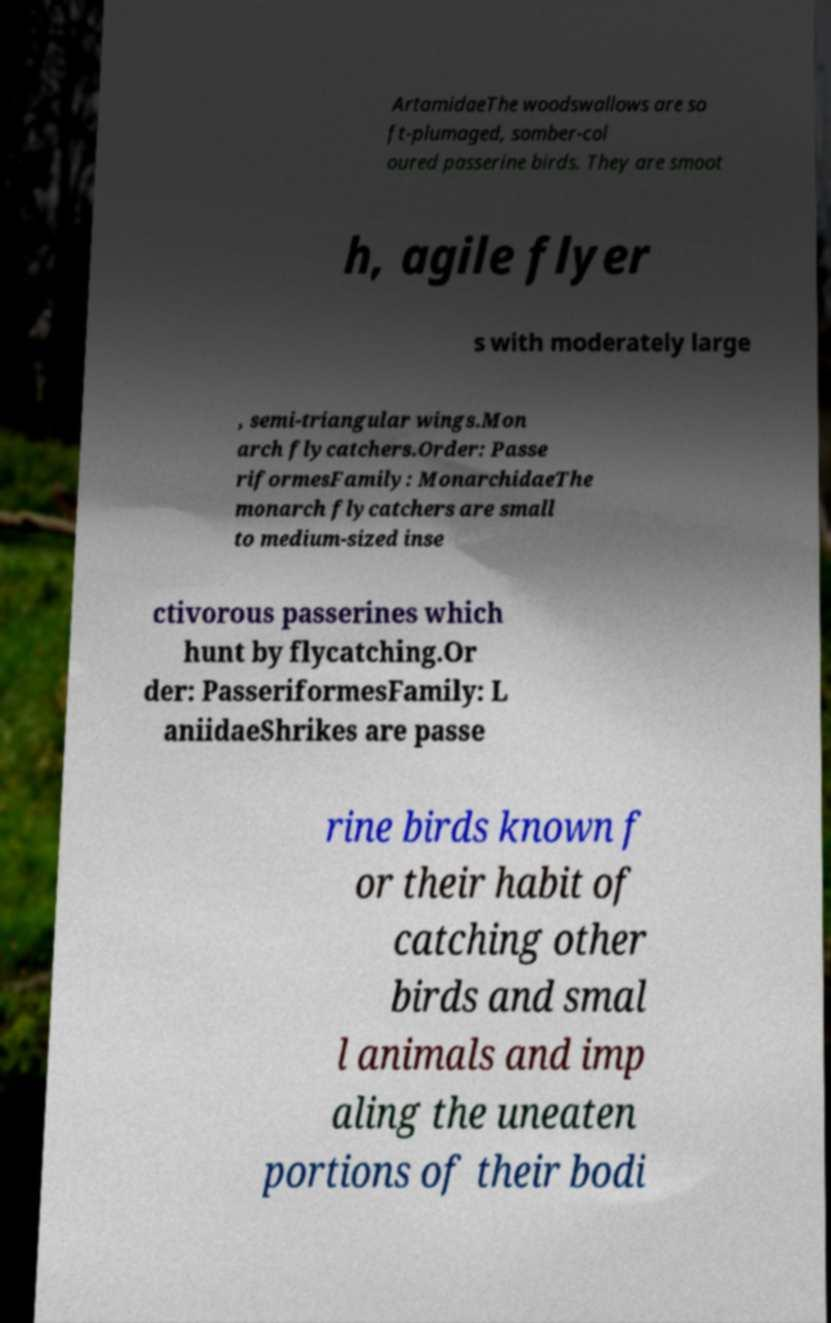Can you read and provide the text displayed in the image?This photo seems to have some interesting text. Can you extract and type it out for me? ArtamidaeThe woodswallows are so ft-plumaged, somber-col oured passerine birds. They are smoot h, agile flyer s with moderately large , semi-triangular wings.Mon arch flycatchers.Order: Passe riformesFamily: MonarchidaeThe monarch flycatchers are small to medium-sized inse ctivorous passerines which hunt by flycatching.Or der: PasseriformesFamily: L aniidaeShrikes are passe rine birds known f or their habit of catching other birds and smal l animals and imp aling the uneaten portions of their bodi 